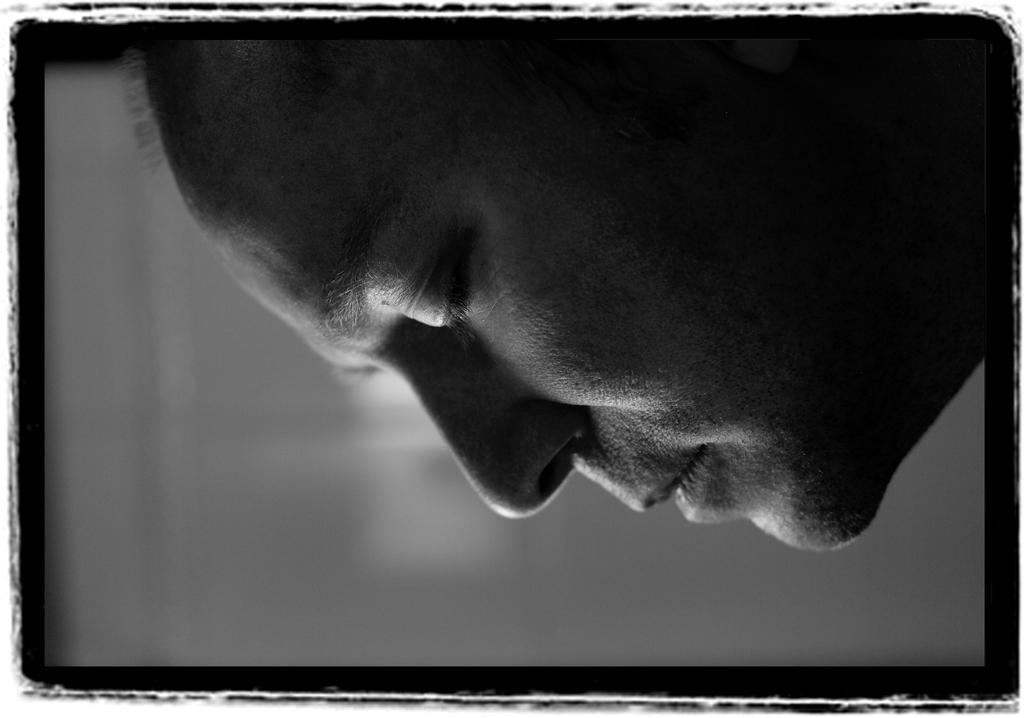What is the main subject of the image? There is a person's face in the image. Can you describe the background of the image? The background of the image is blurry. What idea does the person's face represent in the image? The image does not convey any specific idea or concept related to the person's face. What answer can be found by examining the person's face in the image? There is no answer to be found by examining the person's face in the image, as it is not a question or problem-solving scenario. 